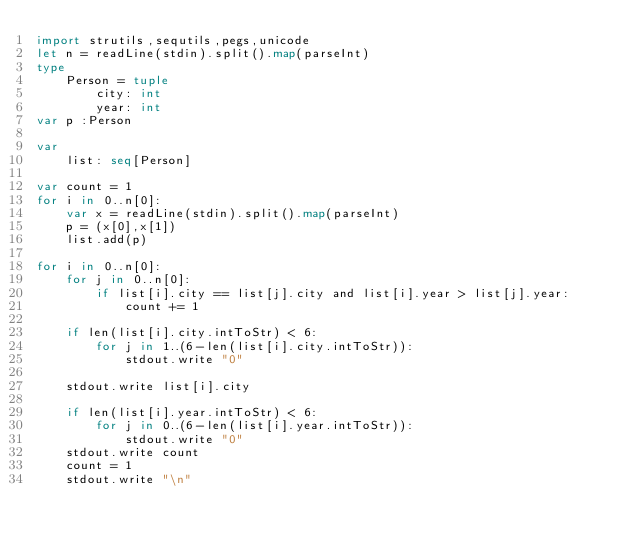Convert code to text. <code><loc_0><loc_0><loc_500><loc_500><_Nim_>import strutils,sequtils,pegs,unicode
let n = readLine(stdin).split().map(parseInt)
type 
    Person = tuple
        city: int
        year: int
var p :Person

var
    list: seq[Person]

var count = 1
for i in 0..n[0]:
    var x = readLine(stdin).split().map(parseInt)
    p = (x[0],x[1])
    list.add(p)

for i in 0..n[0]:
    for j in 0..n[0]:
        if list[i].city == list[j].city and list[i].year > list[j].year:
            count += 1
    
    if len(list[i].city.intToStr) < 6:
        for j in 1..(6-len(list[i].city.intToStr)):
            stdout.write "0"

    stdout.write list[i].city

    if len(list[i].year.intToStr) < 6:
        for j in 0..(6-len(list[i].year.intToStr)):
            stdout.write "0"
    stdout.write count
    count = 1
    stdout.write "\n"</code> 